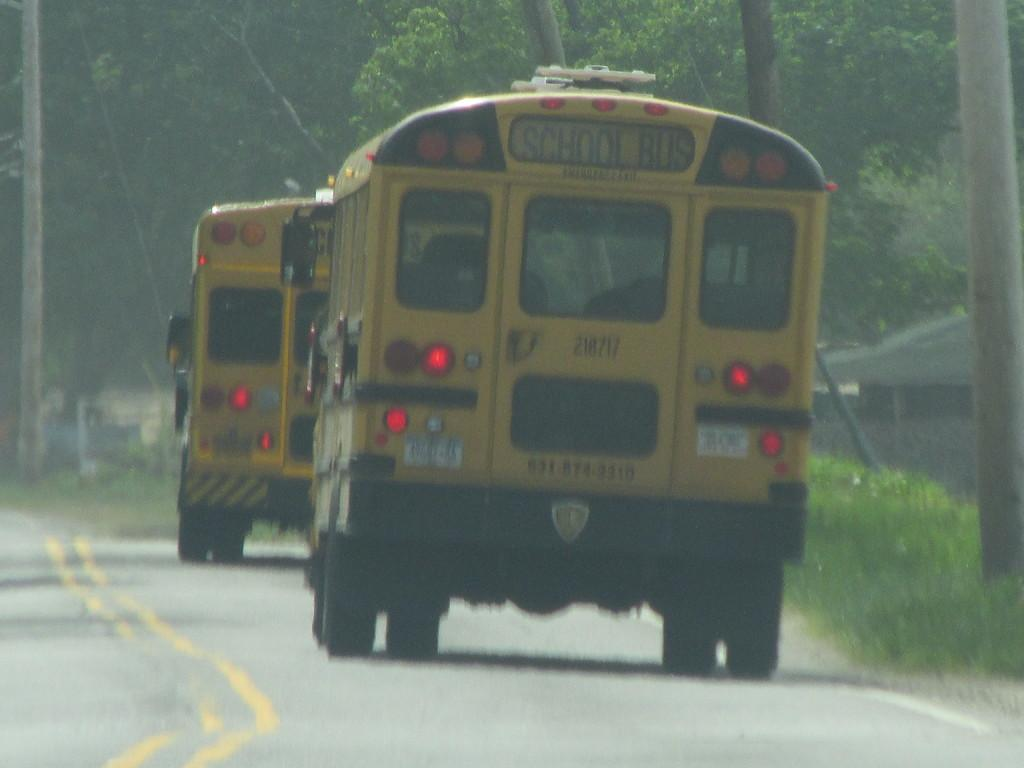What type of vehicles can be seen on the road in the image? There are buses on the road in the image. What can be seen in the background of the image? There are trees and sheds visible in the background of the image. What type of sponge is being used by the maid in the image? There is no sponge or maid present in the image. What scientific experiment is being conducted in the image? There is no scientific experiment or reference to science in the image. 